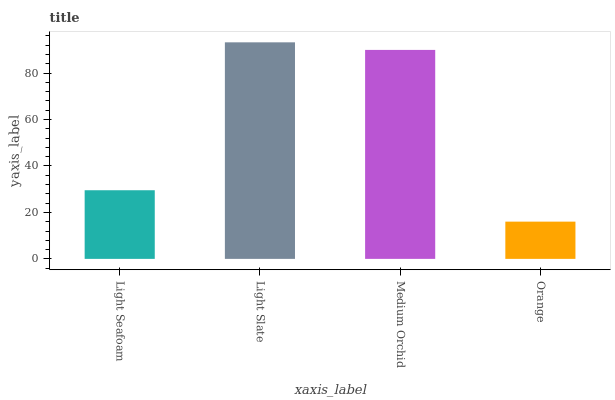Is Medium Orchid the minimum?
Answer yes or no. No. Is Medium Orchid the maximum?
Answer yes or no. No. Is Light Slate greater than Medium Orchid?
Answer yes or no. Yes. Is Medium Orchid less than Light Slate?
Answer yes or no. Yes. Is Medium Orchid greater than Light Slate?
Answer yes or no. No. Is Light Slate less than Medium Orchid?
Answer yes or no. No. Is Medium Orchid the high median?
Answer yes or no. Yes. Is Light Seafoam the low median?
Answer yes or no. Yes. Is Orange the high median?
Answer yes or no. No. Is Medium Orchid the low median?
Answer yes or no. No. 